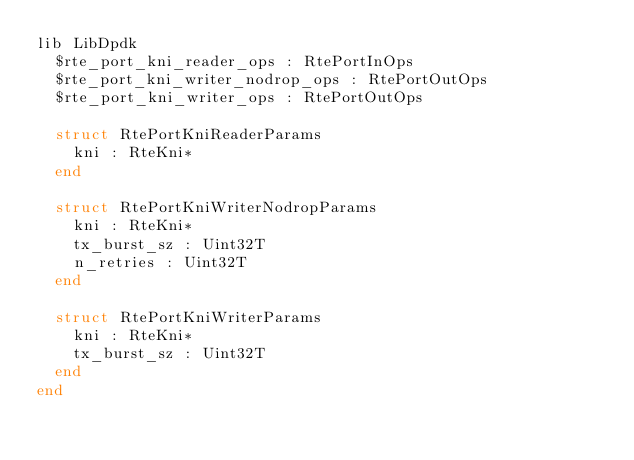Convert code to text. <code><loc_0><loc_0><loc_500><loc_500><_Crystal_>lib LibDpdk
  $rte_port_kni_reader_ops : RtePortInOps
  $rte_port_kni_writer_nodrop_ops : RtePortOutOps
  $rte_port_kni_writer_ops : RtePortOutOps

  struct RtePortKniReaderParams
    kni : RteKni*
  end

  struct RtePortKniWriterNodropParams
    kni : RteKni*
    tx_burst_sz : Uint32T
    n_retries : Uint32T
  end

  struct RtePortKniWriterParams
    kni : RteKni*
    tx_burst_sz : Uint32T
  end
end
</code> 